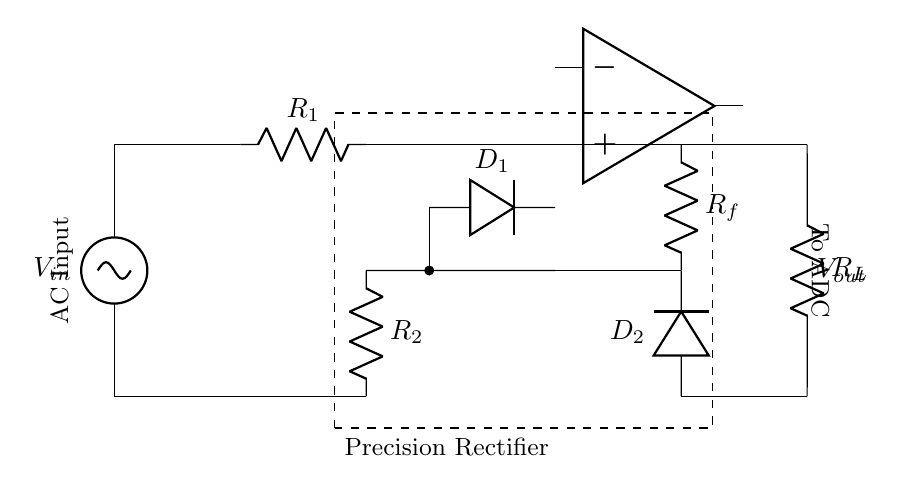What component is used for voltage comparison? The operational amplifier is used for voltage comparison in the circuit. It compares the input voltage with the feedback voltage to control the output.
Answer: operational amplifier How many diodes are present in this circuit? There are two diodes present in the precision rectifier circuit, labeled as D1 and D2.
Answer: two What is the function of resistor R_f? Resistor R_f is a feedback resistor that sets the gain of the operational amplifier and helps to determine the output voltage based on the input voltage.
Answer: feedback What is the relationship between V_out and V_in for this circuit? V_out is equal to the absolute value of V_in, meaning it outputs the rectified positive voltage corresponding to the AC input voltage.
Answer: absolute value What does the dashed rectangle represent? The dashed rectangle encloses the entire precision rectifier circuit, indicating that it is a separate functional block in the overall measurement system.
Answer: precision rectifier What type of input does this circuit accept? The circuit accepts an alternating current (AC) input voltage, as indicated by the labeling of the input connection.
Answer: AC input 